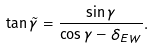<formula> <loc_0><loc_0><loc_500><loc_500>\tan \tilde { \gamma } = \frac { \sin \gamma } { \cos \gamma - \delta _ { E W } } .</formula> 